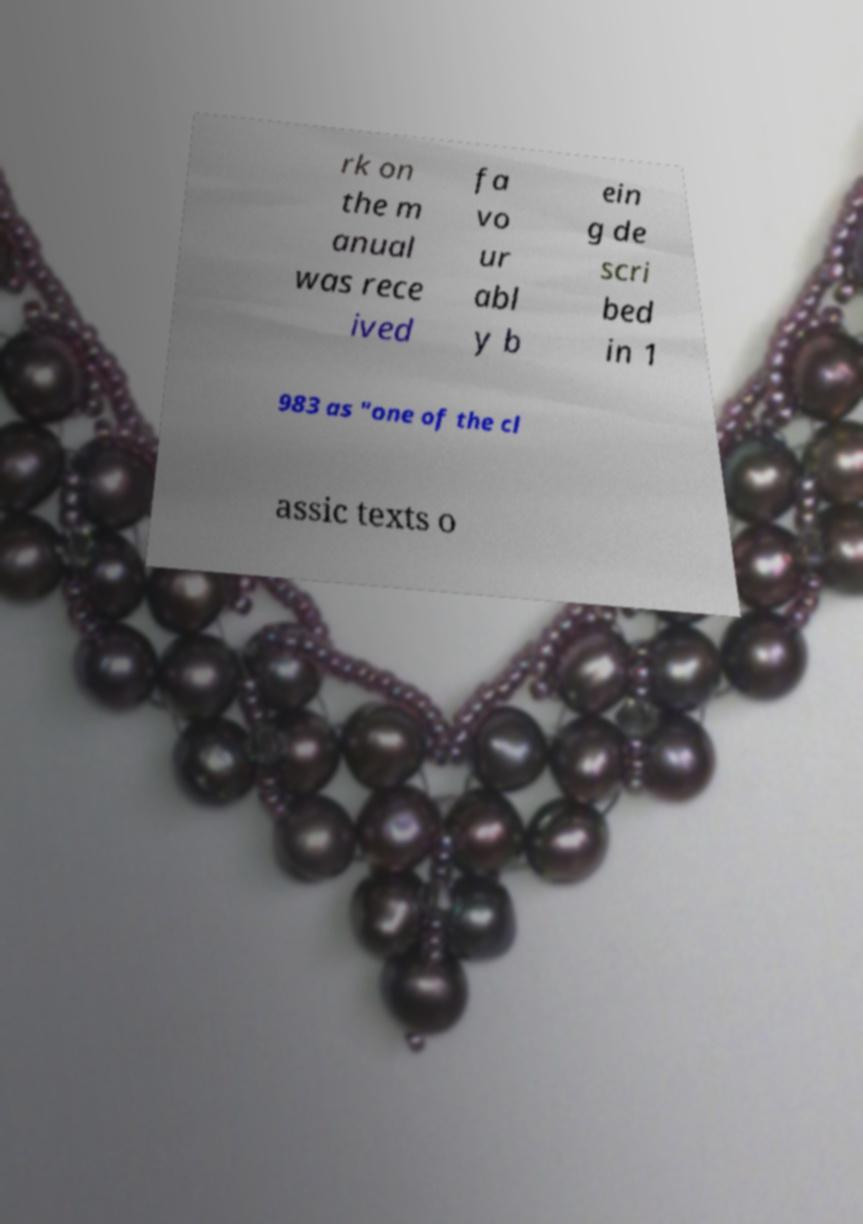For documentation purposes, I need the text within this image transcribed. Could you provide that? rk on the m anual was rece ived fa vo ur abl y b ein g de scri bed in 1 983 as "one of the cl assic texts o 